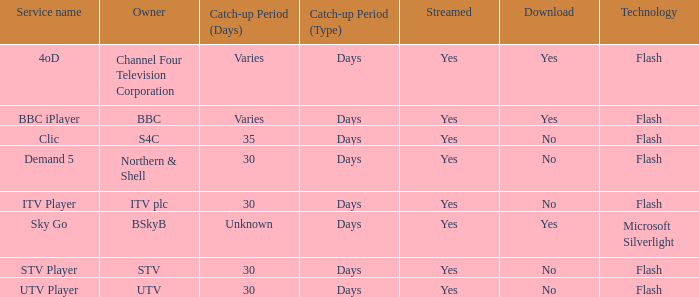What Service Name has UTV as the owner? UTV Player. 